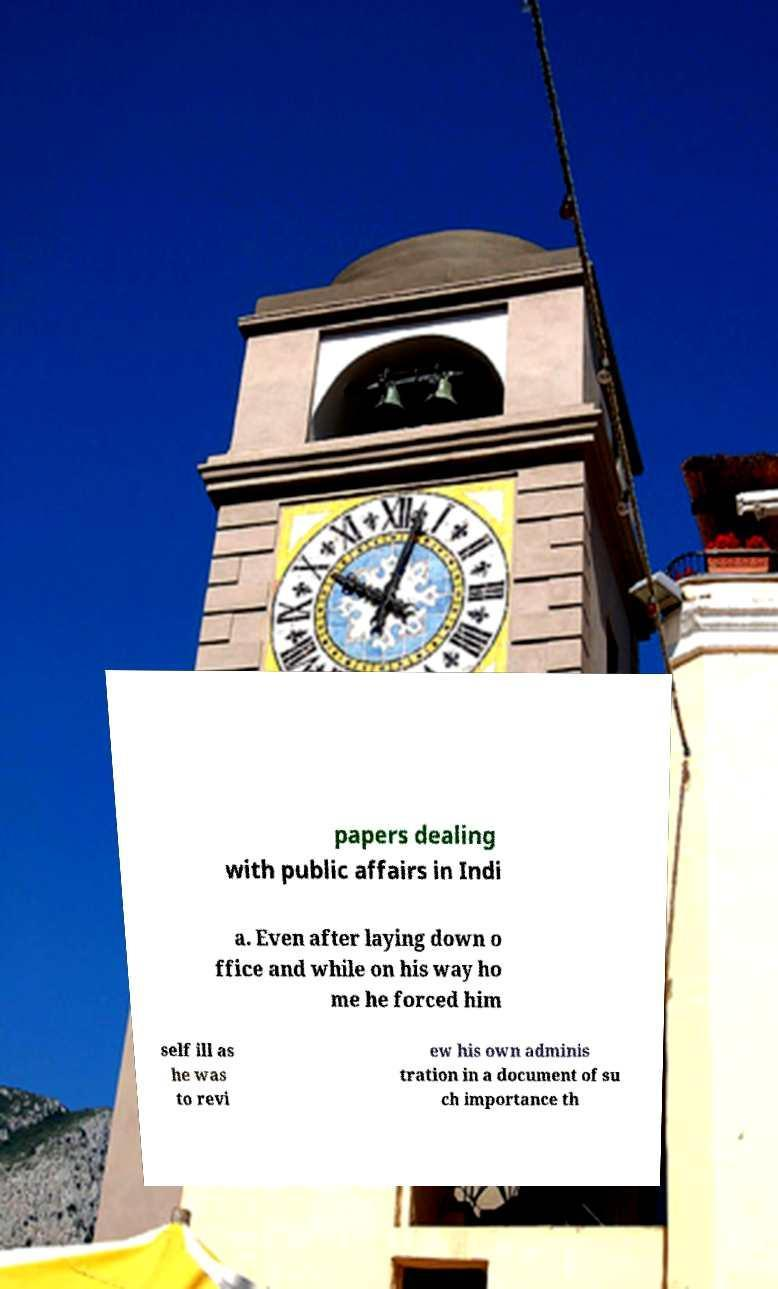Could you assist in decoding the text presented in this image and type it out clearly? papers dealing with public affairs in Indi a. Even after laying down o ffice and while on his way ho me he forced him self ill as he was to revi ew his own adminis tration in a document of su ch importance th 